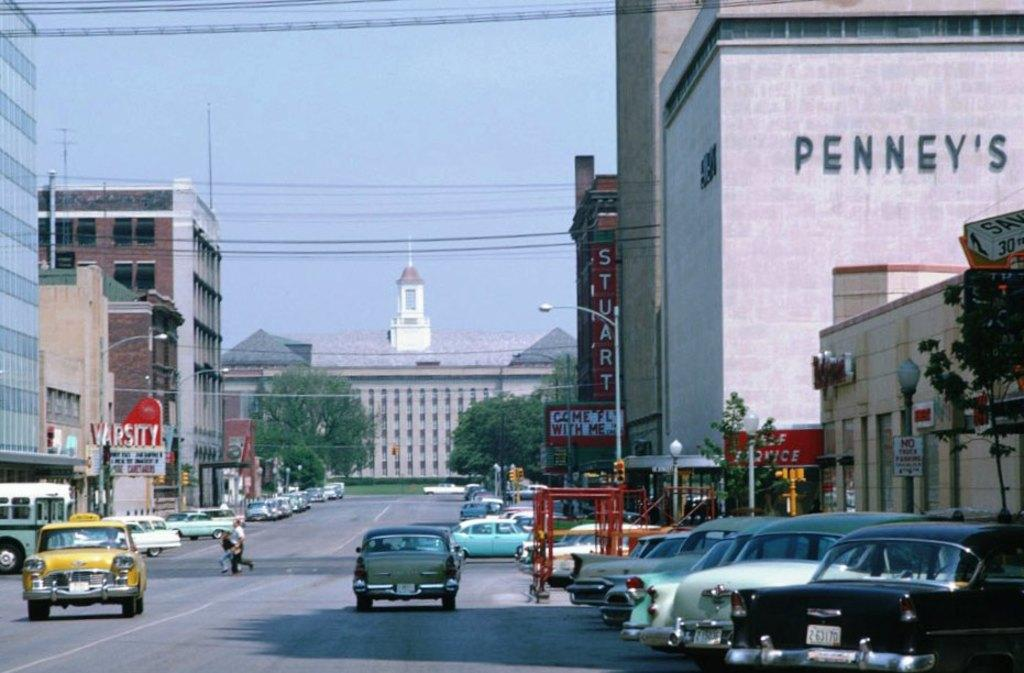Provide a one-sentence caption for the provided image. Old cars drive through a city street next to building with the word Penney's on it. 